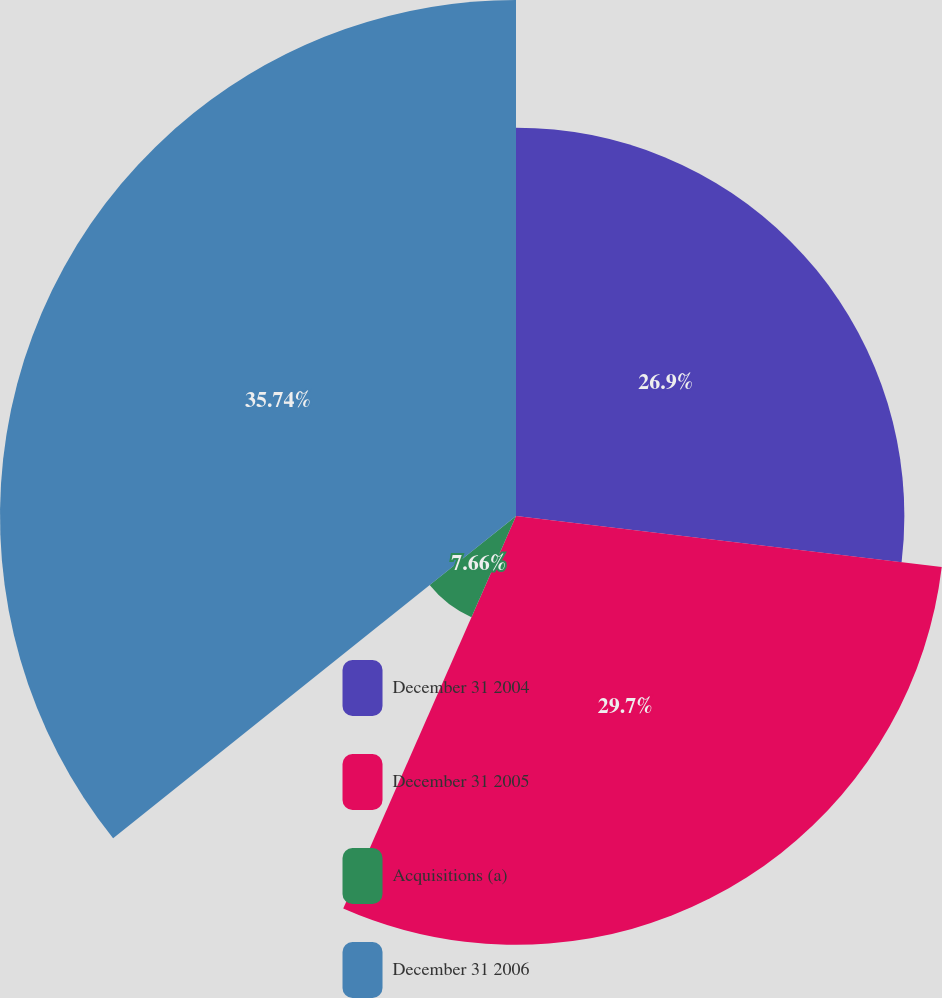Convert chart to OTSL. <chart><loc_0><loc_0><loc_500><loc_500><pie_chart><fcel>December 31 2004<fcel>December 31 2005<fcel>Acquisitions (a)<fcel>December 31 2006<nl><fcel>26.9%<fcel>29.7%<fcel>7.66%<fcel>35.74%<nl></chart> 